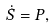<formula> <loc_0><loc_0><loc_500><loc_500>\dot { S } = P ,</formula> 